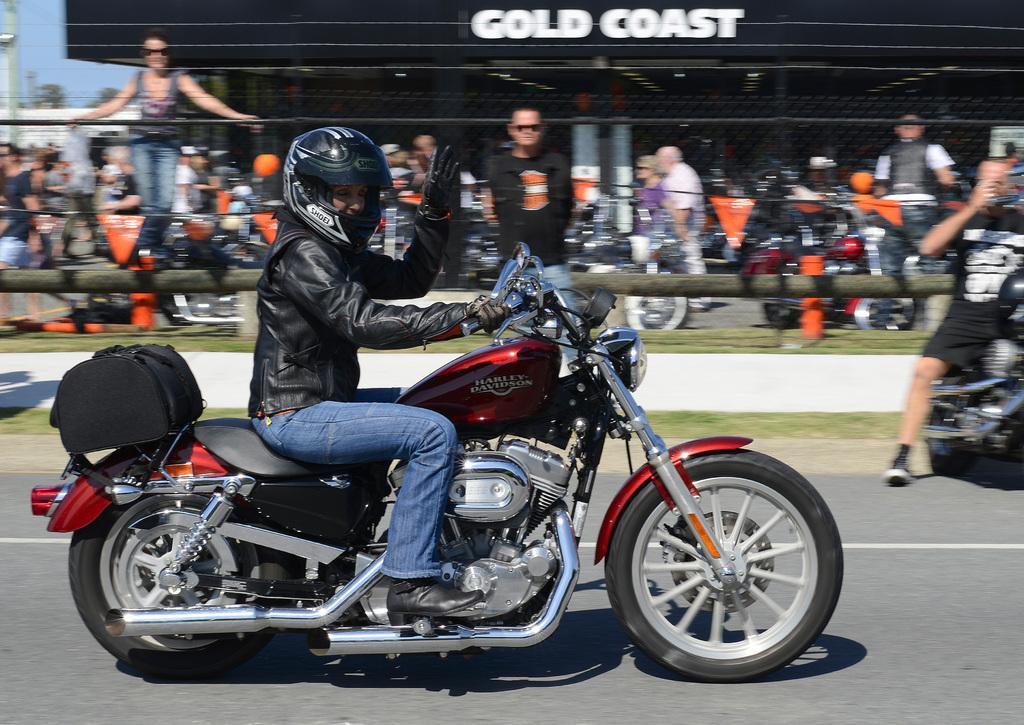Can you describe this image briefly? In this image i can see a person driving a motorbike. He is wearing a jacket, blue jeans and a helmet. In the background i can see few people standing, sky and a building. 